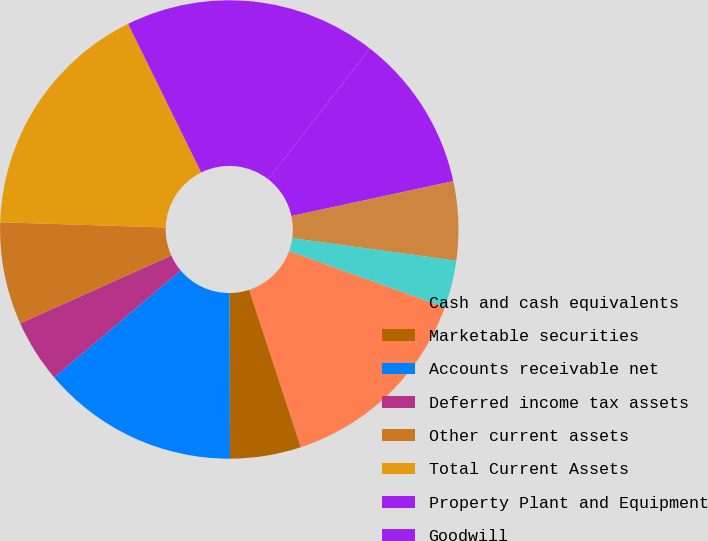<chart> <loc_0><loc_0><loc_500><loc_500><pie_chart><fcel>Cash and cash equivalents<fcel>Marketable securities<fcel>Accounts receivable net<fcel>Deferred income tax assets<fcel>Other current assets<fcel>Total Current Assets<fcel>Property Plant and Equipment<fcel>Goodwill<fcel>Intangible Assets Net<fcel>Investments and Restricted<nl><fcel>14.44%<fcel>5.0%<fcel>13.89%<fcel>4.44%<fcel>7.22%<fcel>17.22%<fcel>17.78%<fcel>11.11%<fcel>5.56%<fcel>3.33%<nl></chart> 